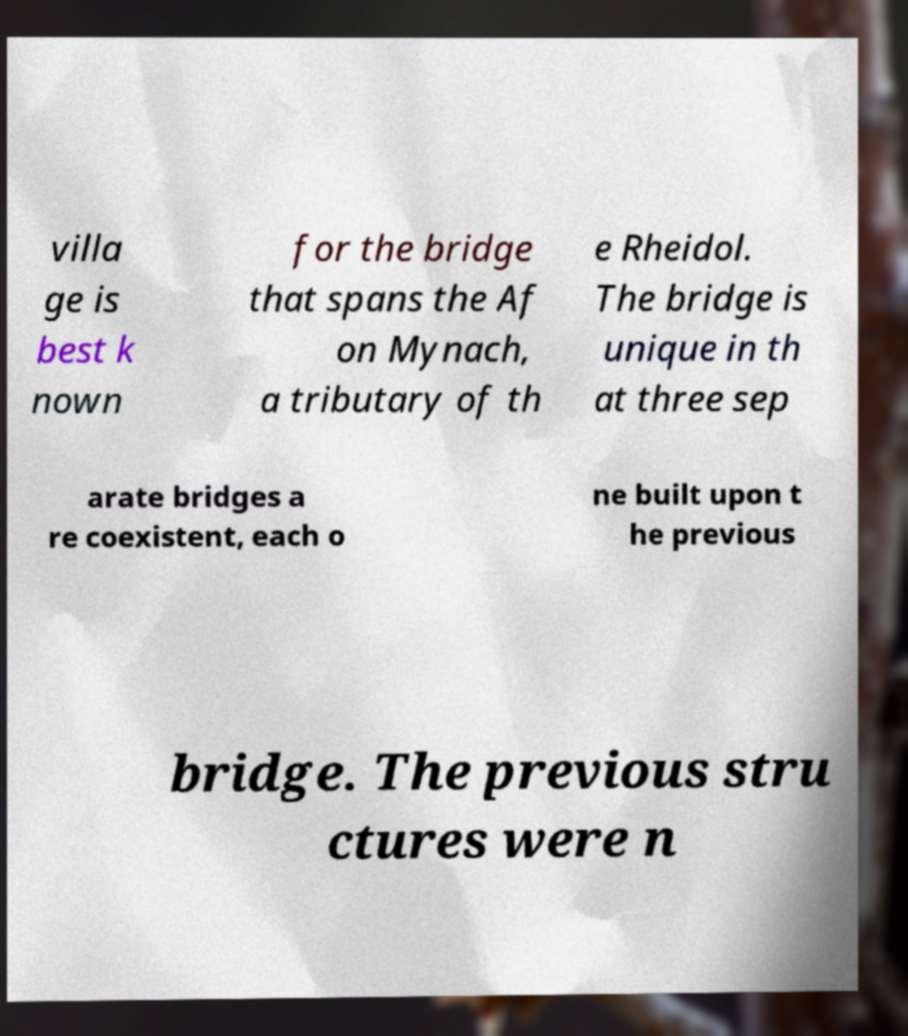What messages or text are displayed in this image? I need them in a readable, typed format. villa ge is best k nown for the bridge that spans the Af on Mynach, a tributary of th e Rheidol. The bridge is unique in th at three sep arate bridges a re coexistent, each o ne built upon t he previous bridge. The previous stru ctures were n 